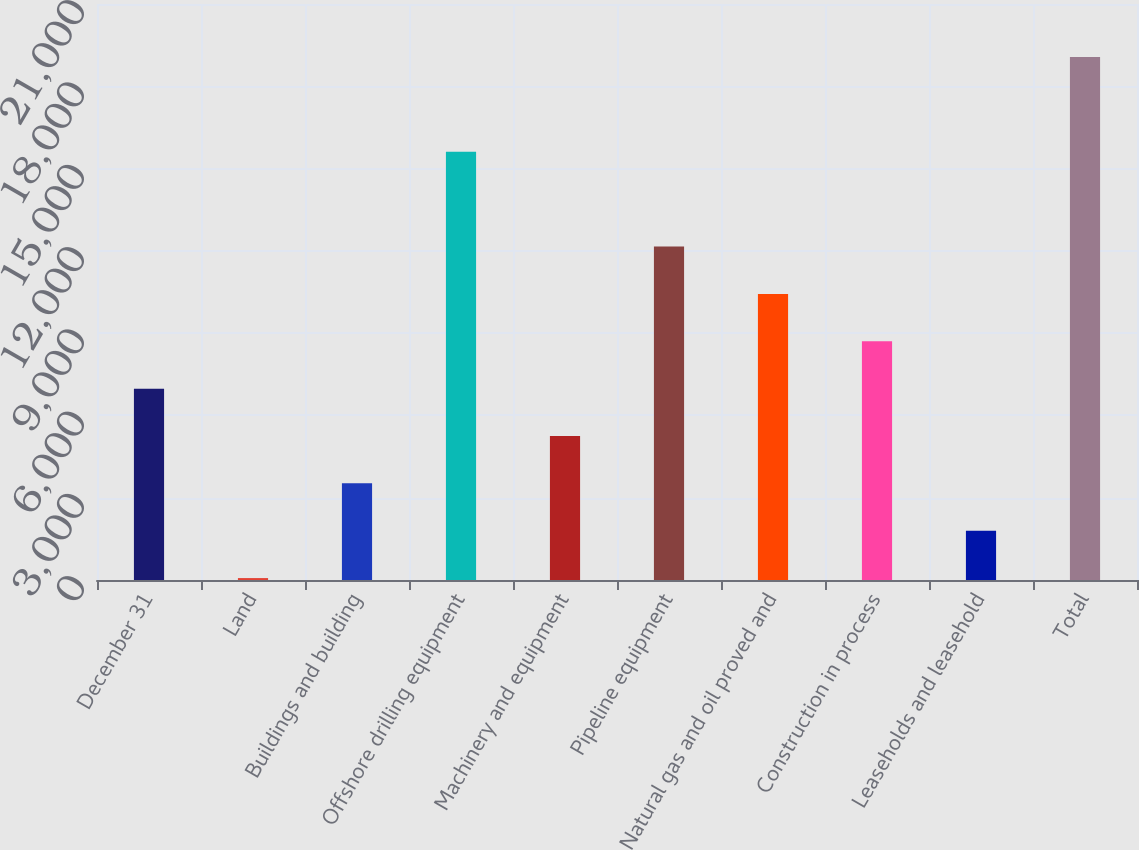<chart> <loc_0><loc_0><loc_500><loc_500><bar_chart><fcel>December 31<fcel>Land<fcel>Buildings and building<fcel>Offshore drilling equipment<fcel>Machinery and equipment<fcel>Pipeline equipment<fcel>Natural gas and oil proved and<fcel>Construction in process<fcel>Leaseholds and leasehold<fcel>Total<nl><fcel>6976.8<fcel>70<fcel>3523.4<fcel>15610.3<fcel>5250.1<fcel>12156.9<fcel>10430.2<fcel>8703.5<fcel>1796.7<fcel>19063.7<nl></chart> 